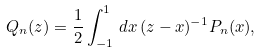Convert formula to latex. <formula><loc_0><loc_0><loc_500><loc_500>Q _ { n } ( z ) = \frac { 1 } { 2 } \int _ { - 1 } ^ { 1 } \, d x \, ( z - x ) ^ { - 1 } P _ { n } ( x ) ,</formula> 